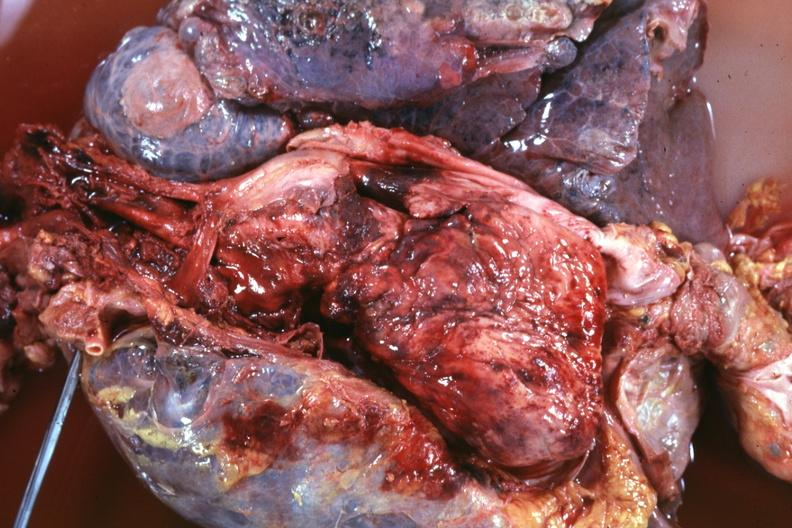where is this part in?
Answer the question using a single word or phrase. Thymus 